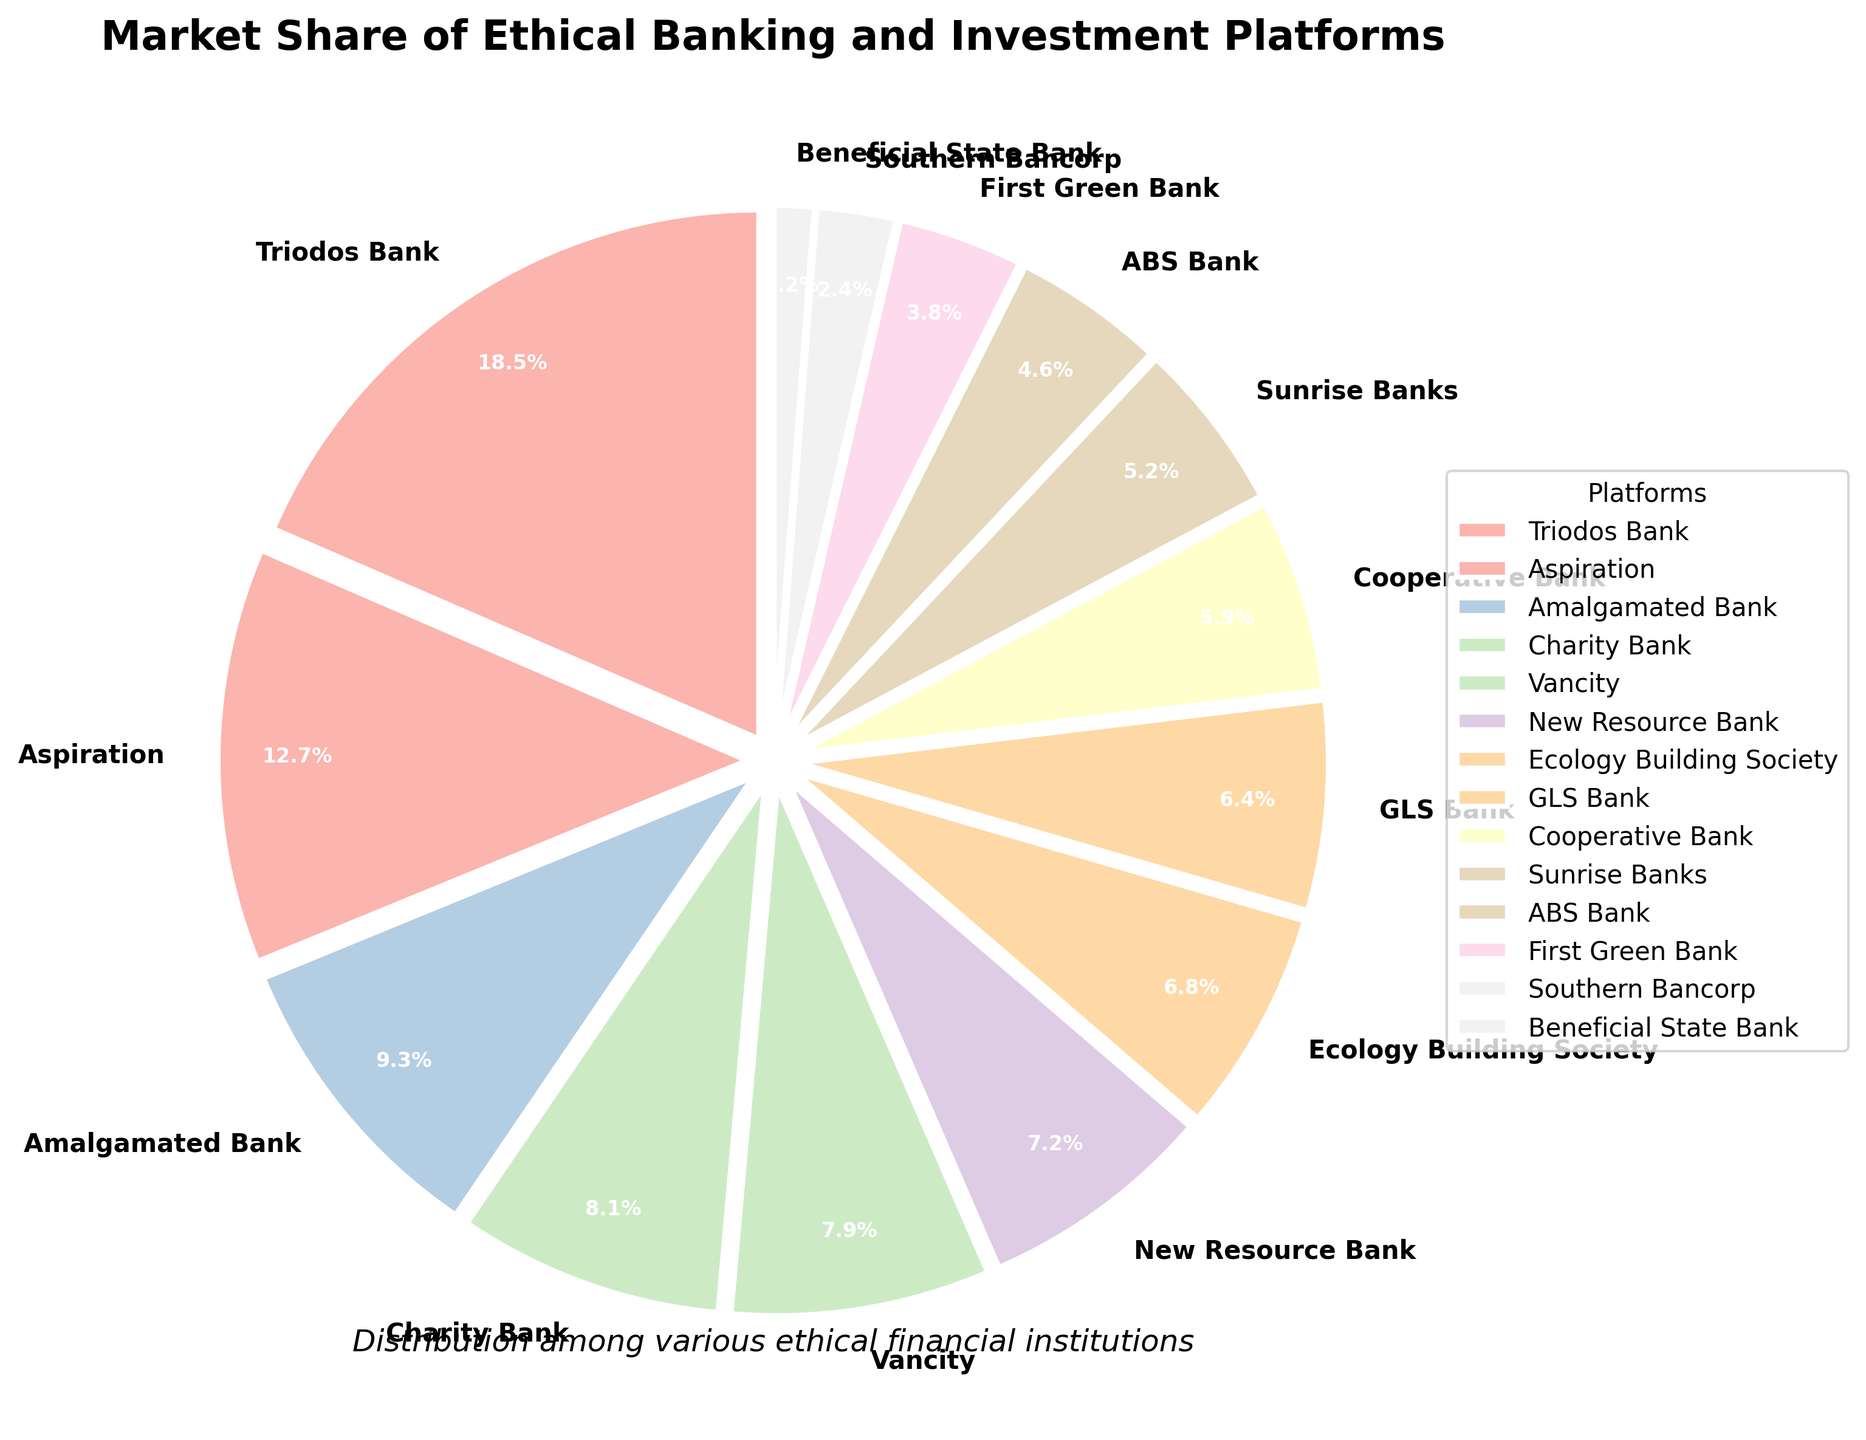What's the market share of the platform with the highest percentage? The figure shows that Triodos Bank has the largest segment in the pie chart. The percentage shown in the segment for Triodos Bank is 18.5%.
Answer: 18.5% Which two platforms together have a combined market share of approximately 22%? Aspiration has a market share of 12.7% and Southern Bancorp has a market share of 2.4%. Adding them together gives 12.7% + 9.3% = 22%.
Answer: Aspiration and Amalgamated Bank Which platform holds a market share of less than 3%? The segment labeled as Beneficial State Bank shows a market share of 1.2%, which is less than 3%.
Answer: Beneficial State Bank What is the total market share held by the top three platforms? The top three platforms based on market share percentages are Triodos Bank, Aspiration, and Amalgamated Bank with 18.5%, 12.7%, and 9.3%, respectively. Summing these gives 18.5% + 12.7% + 9.3% = 40.5%.
Answer: 40.5% How much larger is the market share of GLS Bank compared to First Green Bank? The market share of GLS Bank is 6.4% and that of First Green Bank is 3.8%. Subtracting these gives 6.4% - 3.8% = 2.6%.
Answer: 2.6% Which platform has a market share closest to 5%? The platform with a market share closest to 5% is Sunrise Banks with 5.2%.
Answer: Sunrise Banks What is the difference between the market share of Vancity and Ecology Building Society? The market share of Vancity is 7.9% and that of Ecology Building Society is 6.8%. Subtracting these gives 7.9% - 6.8% = 1.1%.
Answer: 1.1% Which platform has a market share almost equal to Cooperative Bank? The closest market share to Cooperative Bank's 5.9% is Sunrise Banks with 5.2%. The next closest would be ABS Bank with 4.6%, but it's further away from 5.9% than Sunrise Banks.
Answer: Sunrise Banks Which platform's segment appears closest to the title of the pie chart? The segment for Triodos Bank appears closest to the title of the pie chart due to its position in the first quadrant starting from the top.
Answer: Triodos Bank 